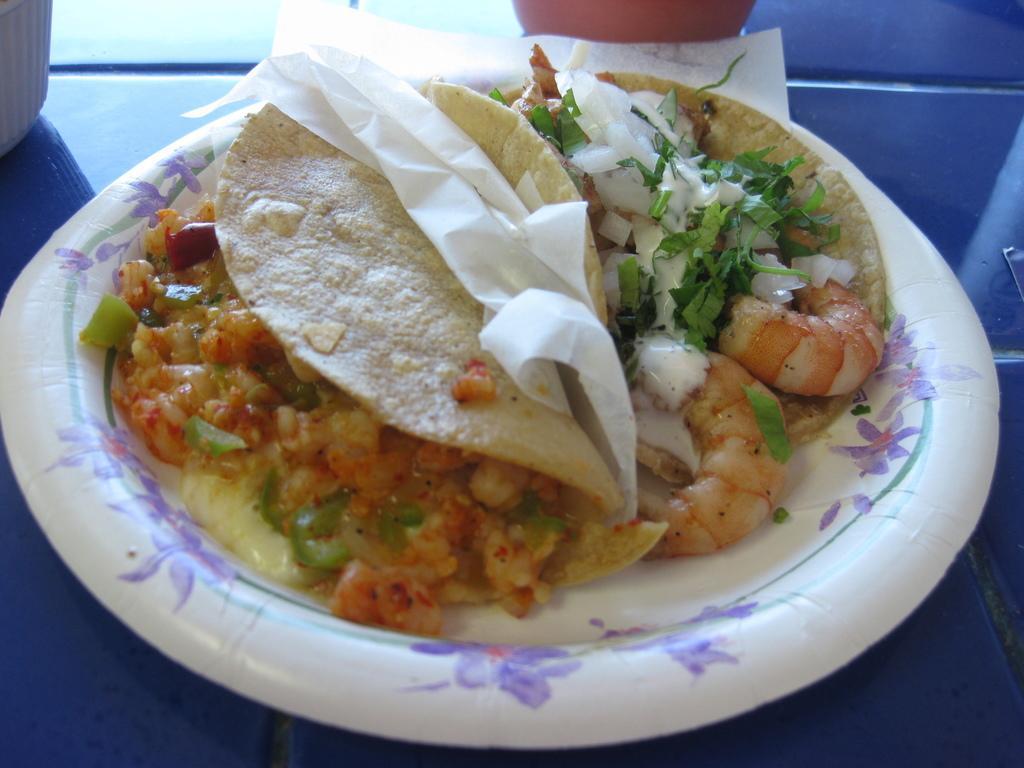Describe this image in one or two sentences. In this image, we can see some food with tissue on the plate. This plate is placed on the blue surface. Top of the image, we can see few objects. 